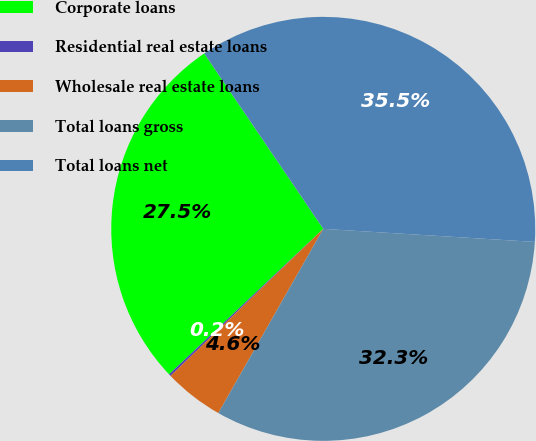Convert chart to OTSL. <chart><loc_0><loc_0><loc_500><loc_500><pie_chart><fcel>Corporate loans<fcel>Residential real estate loans<fcel>Wholesale real estate loans<fcel>Total loans gross<fcel>Total loans net<nl><fcel>27.55%<fcel>0.16%<fcel>4.56%<fcel>32.26%<fcel>35.47%<nl></chart> 